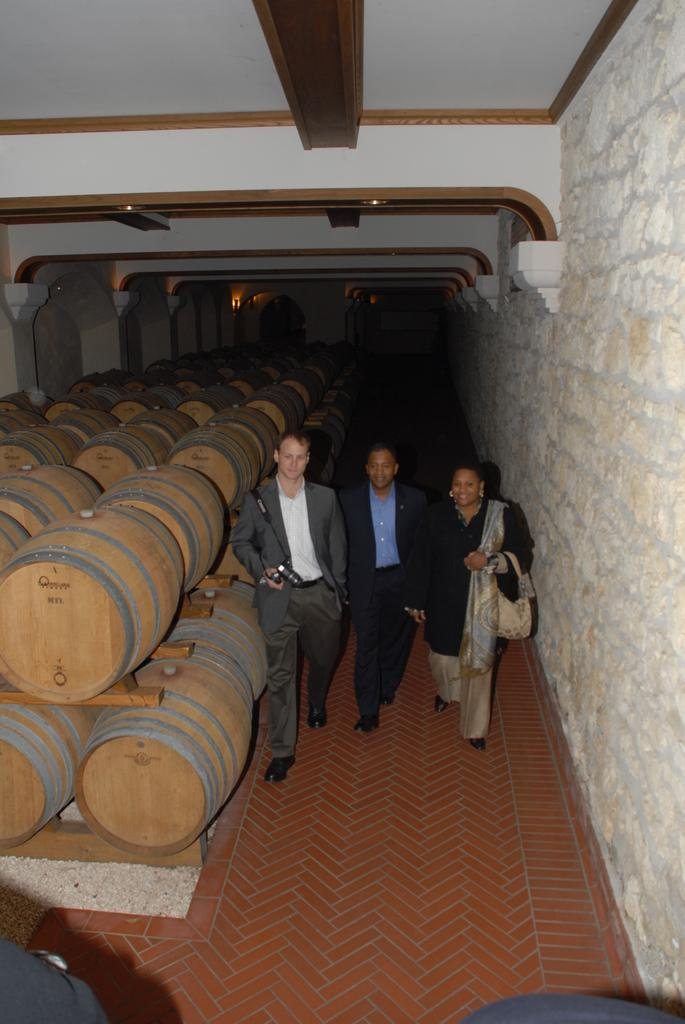What can be seen in the image that is related to storage or transportation? There is a group of barrels in the image. What are the people in the image doing? The people are walking in the image. On what surface are the people walking? The people are walking on the ground. What can be seen in the background of the image? There is a wall, a ceiling, and lights in the background of the image. How many people are walking in the image? There are three people walking in the image. Can you tell me what type of watch the person in the image is wearing? There is no watch visible in the image. Is there a playground present in the image? There is no playground present in the image. 